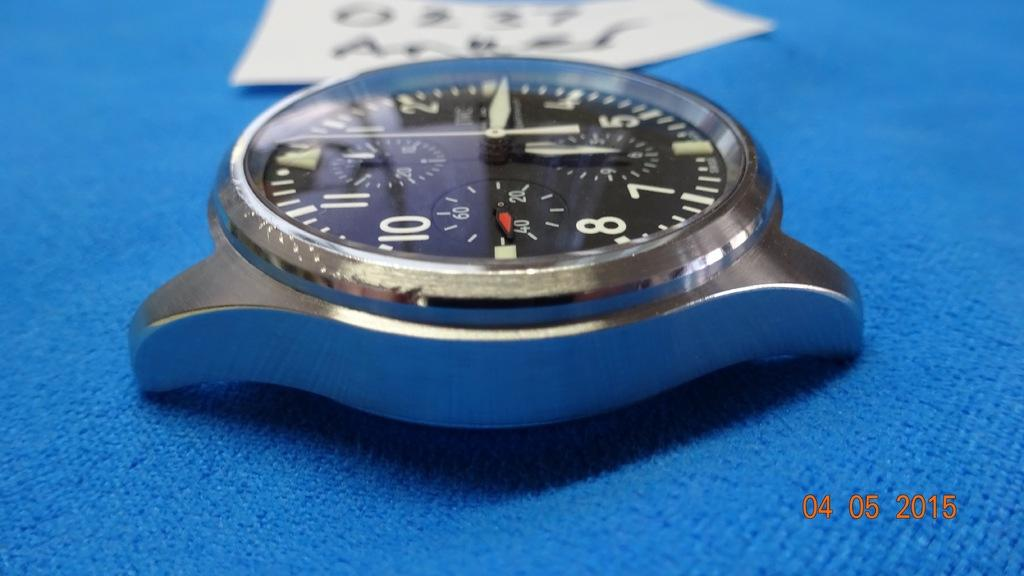<image>
Present a compact description of the photo's key features. An image dated 04 05 2015 depicts the face of a watch. 